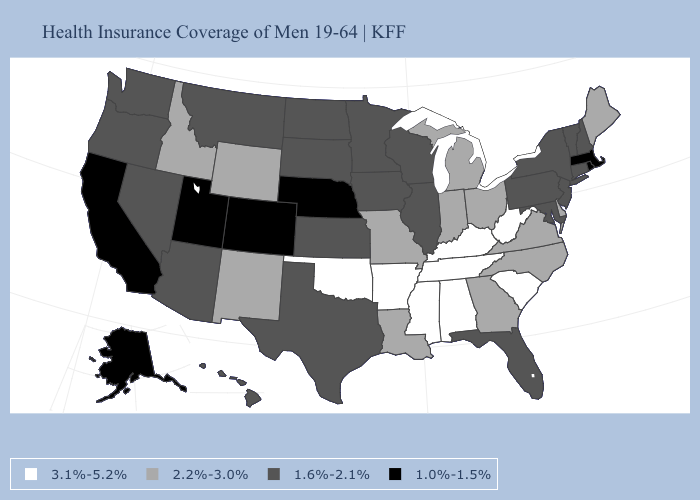Name the states that have a value in the range 1.0%-1.5%?
Be succinct. Alaska, California, Colorado, Massachusetts, Nebraska, Rhode Island, Utah. Name the states that have a value in the range 1.6%-2.1%?
Answer briefly. Arizona, Connecticut, Florida, Hawaii, Illinois, Iowa, Kansas, Maryland, Minnesota, Montana, Nevada, New Hampshire, New Jersey, New York, North Dakota, Oregon, Pennsylvania, South Dakota, Texas, Vermont, Washington, Wisconsin. Which states have the lowest value in the USA?
Quick response, please. Alaska, California, Colorado, Massachusetts, Nebraska, Rhode Island, Utah. Does the map have missing data?
Be succinct. No. What is the highest value in the Northeast ?
Answer briefly. 2.2%-3.0%. Does Alaska have the lowest value in the West?
Write a very short answer. Yes. What is the highest value in the Northeast ?
Be succinct. 2.2%-3.0%. Name the states that have a value in the range 1.0%-1.5%?
Keep it brief. Alaska, California, Colorado, Massachusetts, Nebraska, Rhode Island, Utah. What is the value of Iowa?
Quick response, please. 1.6%-2.1%. Does the first symbol in the legend represent the smallest category?
Keep it brief. No. Which states hav the highest value in the West?
Be succinct. Idaho, New Mexico, Wyoming. Does Idaho have the highest value in the West?
Be succinct. Yes. Which states have the highest value in the USA?
Give a very brief answer. Alabama, Arkansas, Kentucky, Mississippi, Oklahoma, South Carolina, Tennessee, West Virginia. 